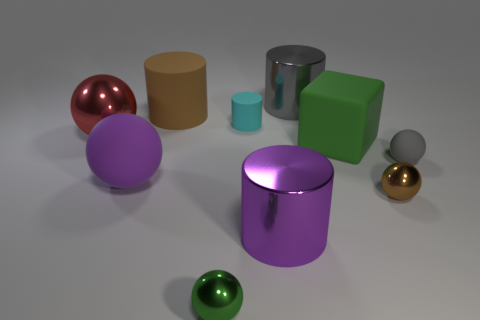Is there anything else that has the same color as the matte block?
Ensure brevity in your answer.  Yes. There is a purple thing that is made of the same material as the small brown ball; what shape is it?
Ensure brevity in your answer.  Cylinder. Do the tiny cyan rubber thing and the brown thing that is behind the big metallic sphere have the same shape?
Your answer should be compact. Yes. There is a purple thing left of the brown object behind the big red thing; what is its material?
Provide a short and direct response. Rubber. Are there an equal number of shiny objects that are in front of the large gray metal cylinder and cylinders?
Give a very brief answer. Yes. Is the color of the metallic cylinder in front of the red metallic ball the same as the matte ball that is left of the cyan thing?
Provide a succinct answer. Yes. What number of small things are both on the left side of the brown metal sphere and behind the big rubber ball?
Provide a short and direct response. 1. What number of other things are the same shape as the large gray object?
Give a very brief answer. 3. Is the number of small shiny objects that are on the right side of the gray metallic object greater than the number of small purple shiny cubes?
Keep it short and to the point. Yes. The tiny matte object left of the tiny gray rubber sphere is what color?
Your answer should be very brief. Cyan. 